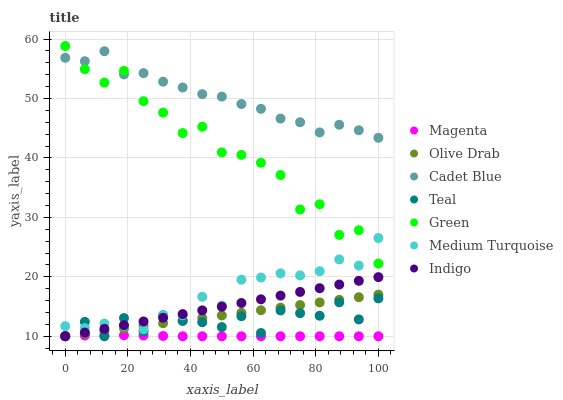Does Magenta have the minimum area under the curve?
Answer yes or no. Yes. Does Cadet Blue have the maximum area under the curve?
Answer yes or no. Yes. Does Indigo have the minimum area under the curve?
Answer yes or no. No. Does Indigo have the maximum area under the curve?
Answer yes or no. No. Is Olive Drab the smoothest?
Answer yes or no. Yes. Is Green the roughest?
Answer yes or no. Yes. Is Indigo the smoothest?
Answer yes or no. No. Is Indigo the roughest?
Answer yes or no. No. Does Indigo have the lowest value?
Answer yes or no. Yes. Does Medium Turquoise have the lowest value?
Answer yes or no. No. Does Green have the highest value?
Answer yes or no. Yes. Does Indigo have the highest value?
Answer yes or no. No. Is Olive Drab less than Cadet Blue?
Answer yes or no. Yes. Is Cadet Blue greater than Indigo?
Answer yes or no. Yes. Does Teal intersect Indigo?
Answer yes or no. Yes. Is Teal less than Indigo?
Answer yes or no. No. Is Teal greater than Indigo?
Answer yes or no. No. Does Olive Drab intersect Cadet Blue?
Answer yes or no. No. 